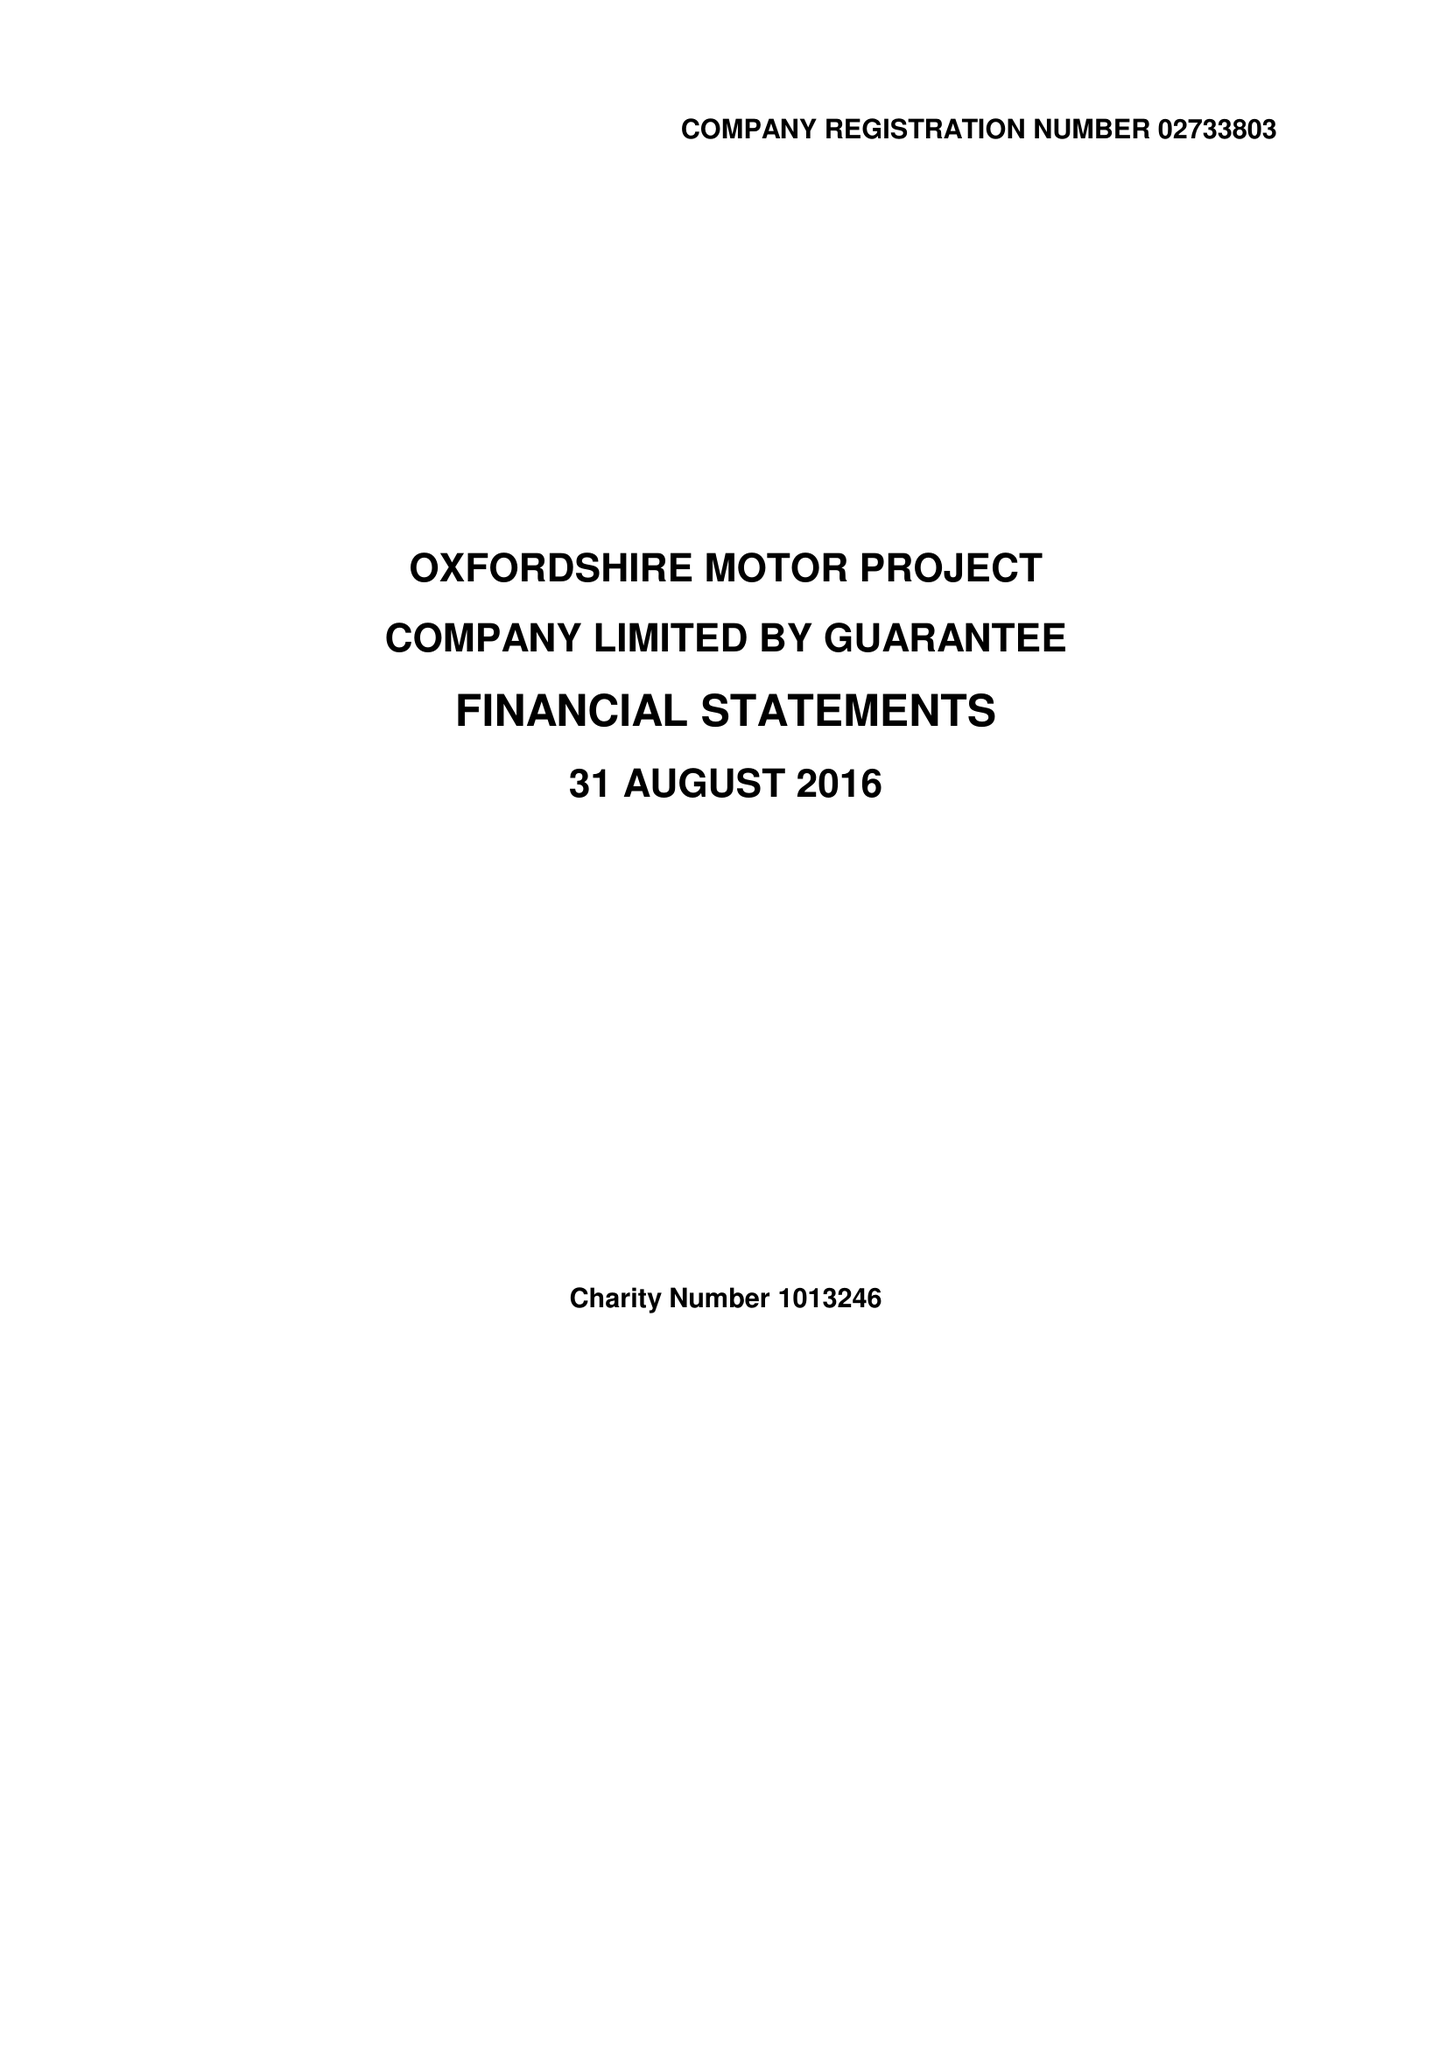What is the value for the spending_annually_in_british_pounds?
Answer the question using a single word or phrase. 294997.00 